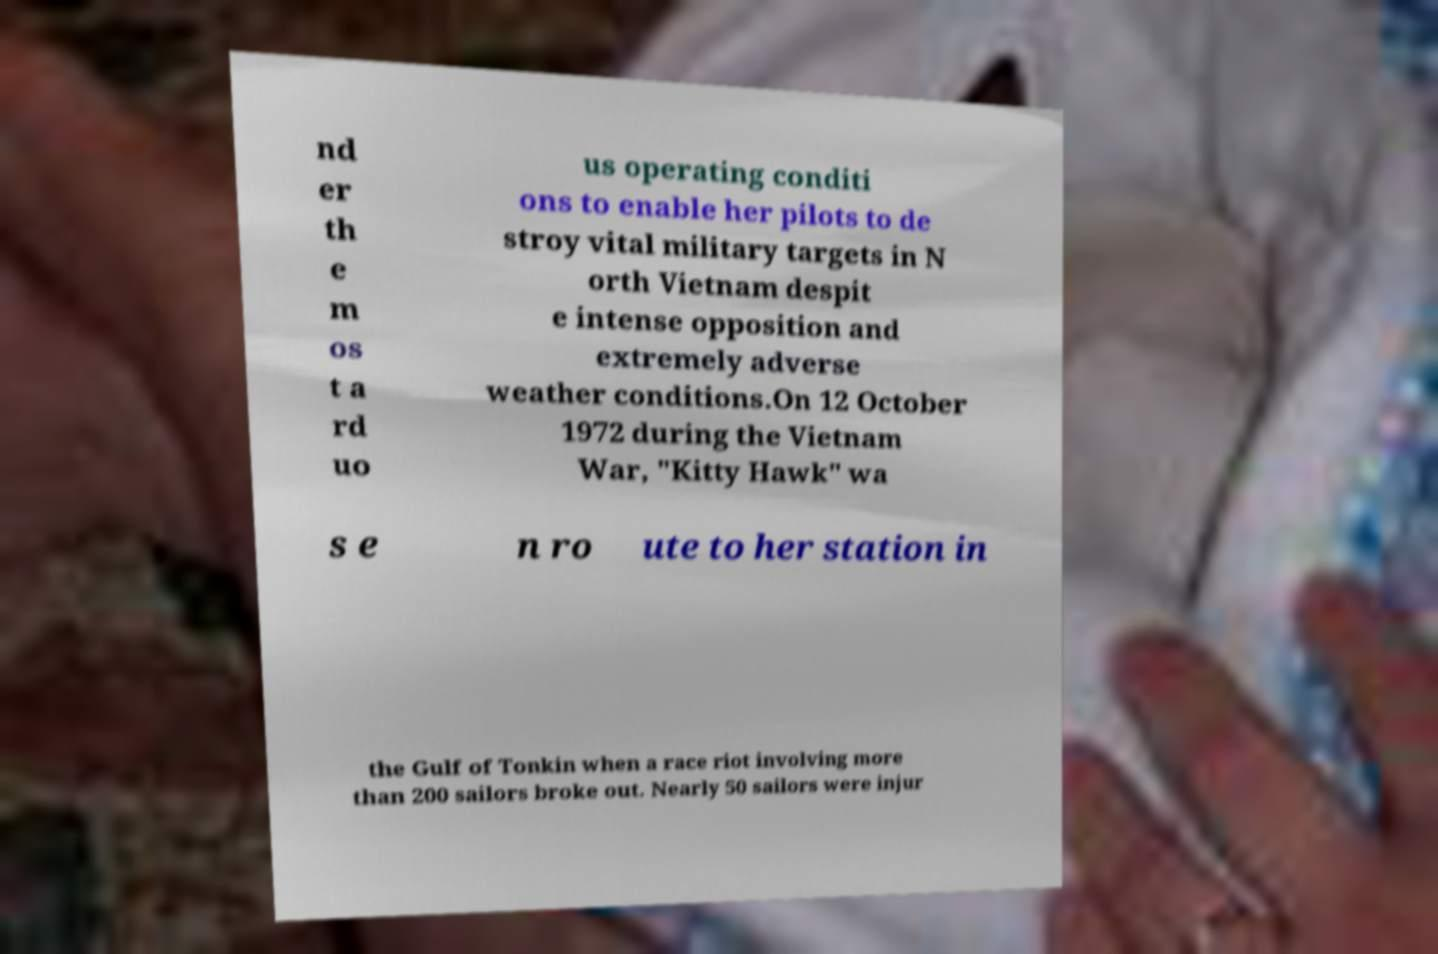What messages or text are displayed in this image? I need them in a readable, typed format. nd er th e m os t a rd uo us operating conditi ons to enable her pilots to de stroy vital military targets in N orth Vietnam despit e intense opposition and extremely adverse weather conditions.On 12 October 1972 during the Vietnam War, "Kitty Hawk" wa s e n ro ute to her station in the Gulf of Tonkin when a race riot involving more than 200 sailors broke out. Nearly 50 sailors were injur 